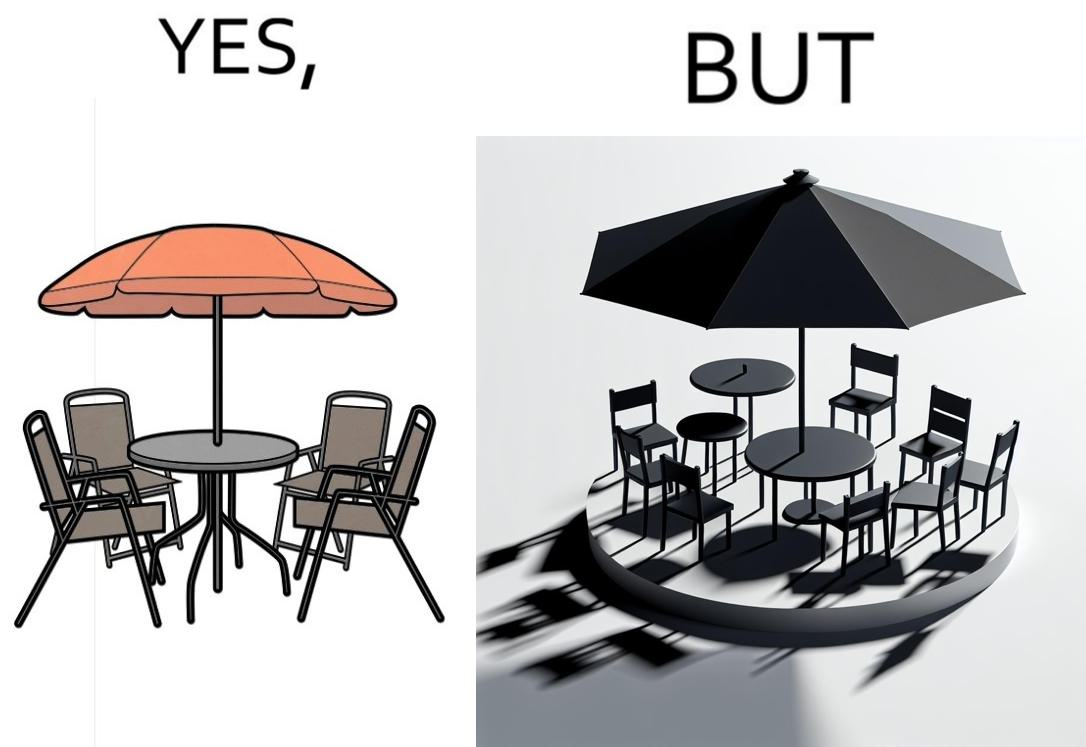What is shown in the left half versus the right half of this image? In the left part of the image: Chairs surrounding a table under a large umbrella. In the right part of the image: Chairs surrounding a table under a large umbrella, with the shadow of the umbrella appearing on the side. 